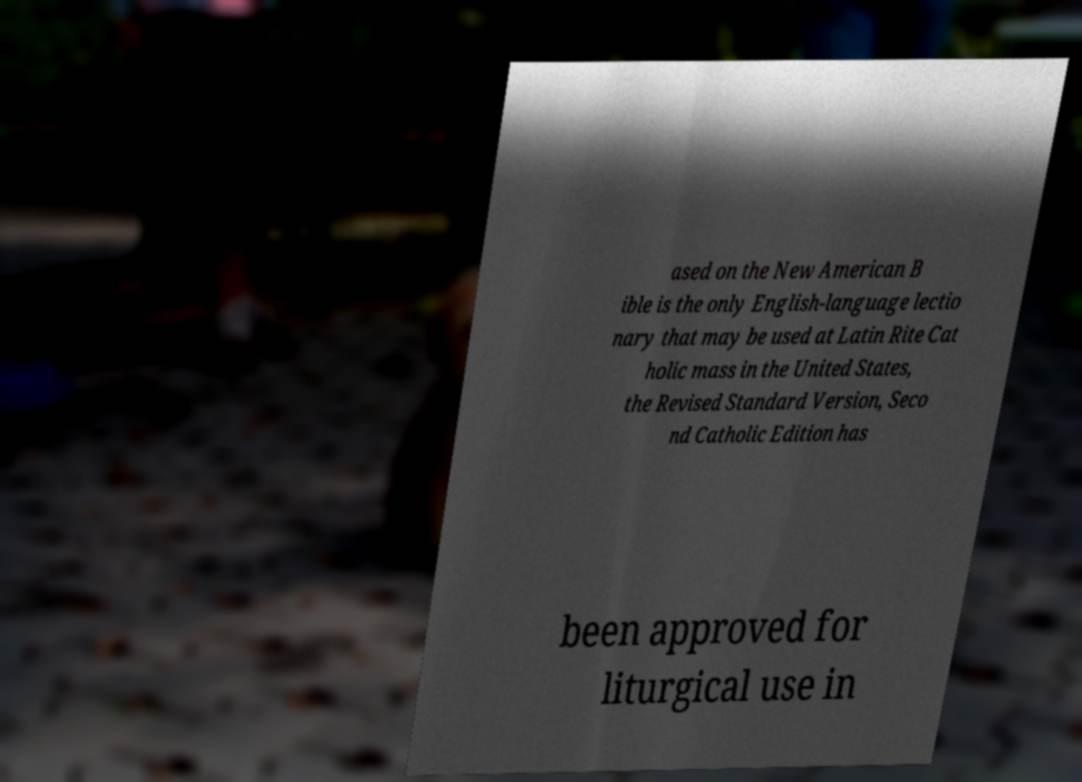Can you read and provide the text displayed in the image?This photo seems to have some interesting text. Can you extract and type it out for me? ased on the New American B ible is the only English-language lectio nary that may be used at Latin Rite Cat holic mass in the United States, the Revised Standard Version, Seco nd Catholic Edition has been approved for liturgical use in 